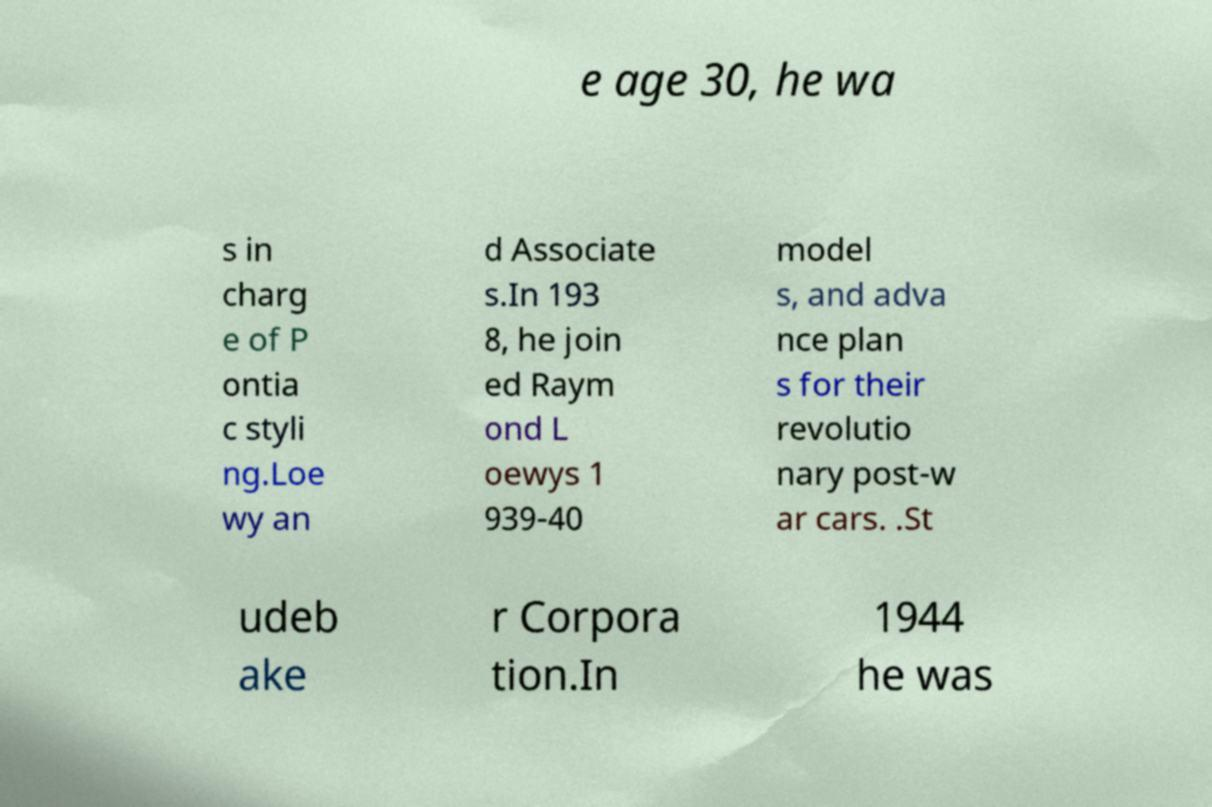Please identify and transcribe the text found in this image. e age 30, he wa s in charg e of P ontia c styli ng.Loe wy an d Associate s.In 193 8, he join ed Raym ond L oewys 1 939-40 model s, and adva nce plan s for their revolutio nary post-w ar cars. .St udeb ake r Corpora tion.In 1944 he was 